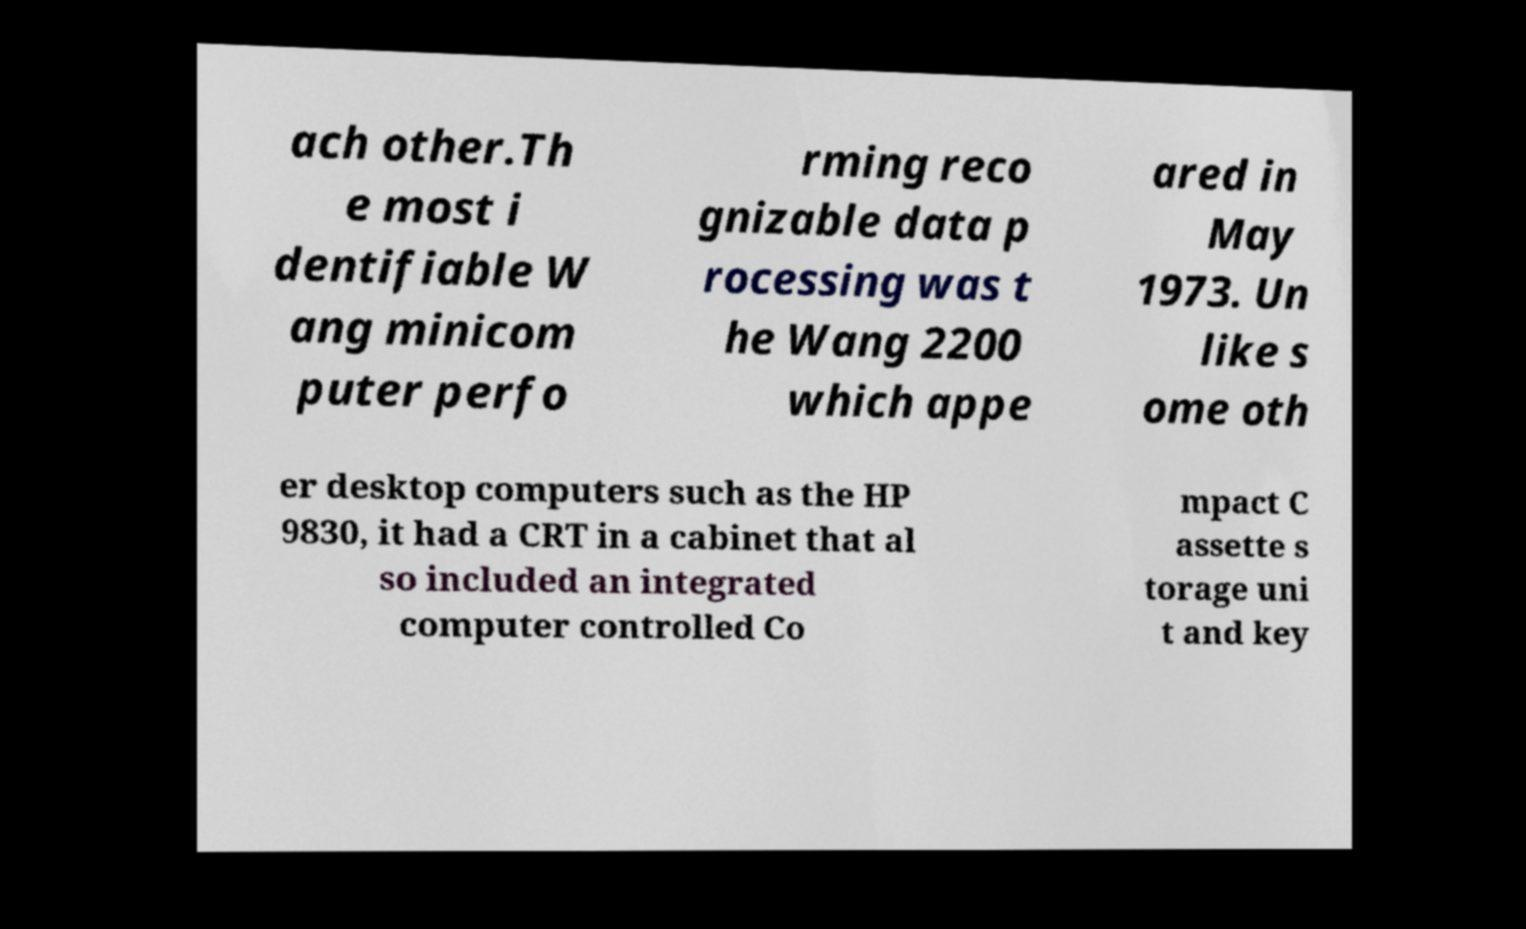Could you assist in decoding the text presented in this image and type it out clearly? ach other.Th e most i dentifiable W ang minicom puter perfo rming reco gnizable data p rocessing was t he Wang 2200 which appe ared in May 1973. Un like s ome oth er desktop computers such as the HP 9830, it had a CRT in a cabinet that al so included an integrated computer controlled Co mpact C assette s torage uni t and key 